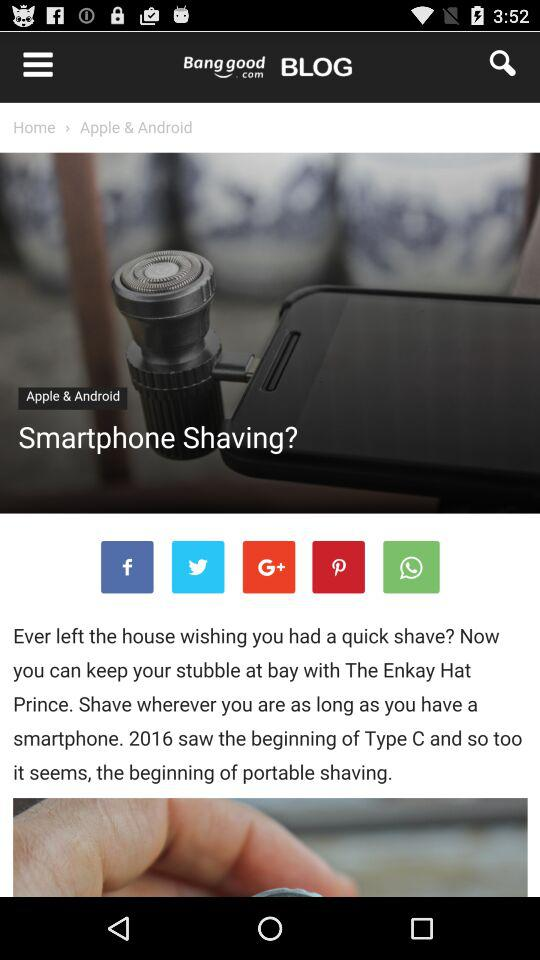What's the selected category? The selected categories are "Clothing and Apparel", "Women" and "Bottoms". 